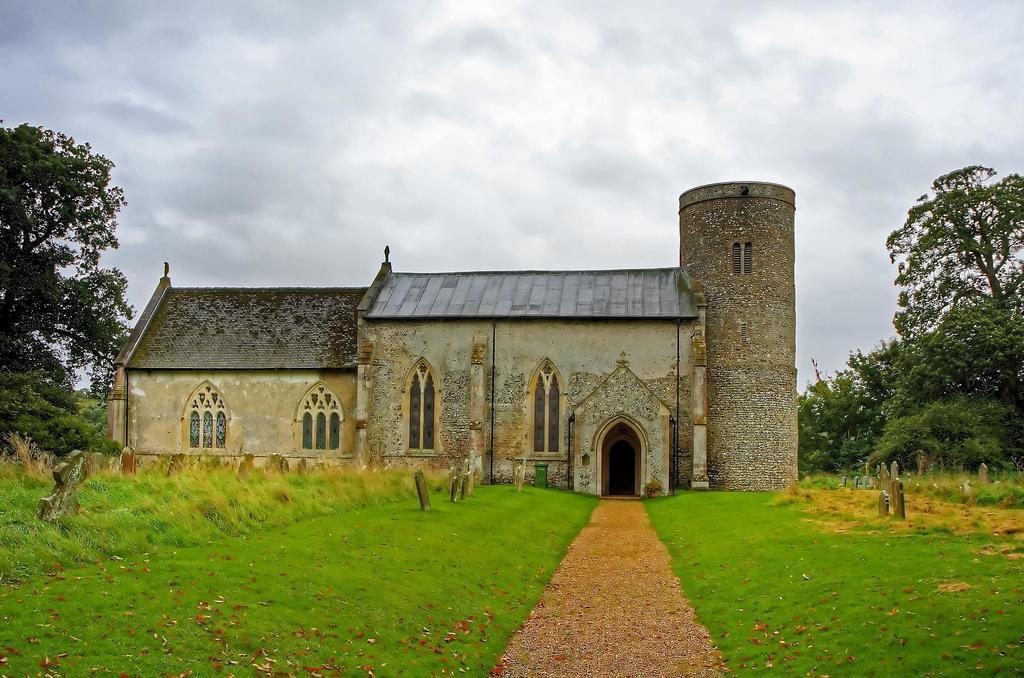Describe this image in one or two sentences. In this picture we can see the brick house with roof tile in the center of the image. In the front there is a walking path and both side there is a grass lawn. In the background we can see some trees. 